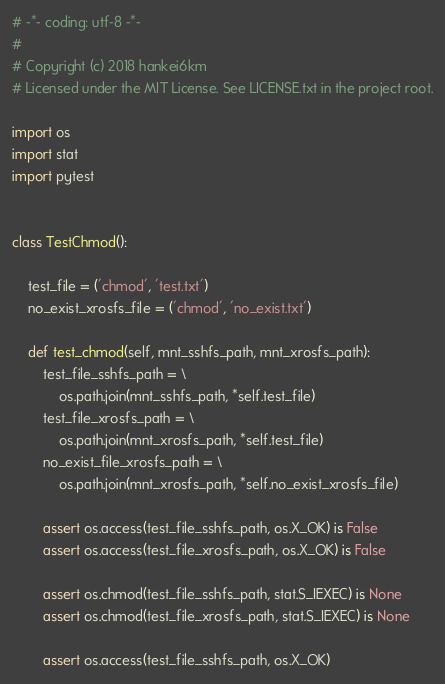Convert code to text. <code><loc_0><loc_0><loc_500><loc_500><_Python_># -*- coding: utf-8 -*-
#
# Copyright (c) 2018 hankei6km
# Licensed under the MIT License. See LICENSE.txt in the project root.

import os
import stat
import pytest


class TestChmod():

    test_file = ('chmod', 'test.txt')
    no_exist_xrosfs_file = ('chmod', 'no_exist.txt')

    def test_chmod(self, mnt_sshfs_path, mnt_xrosfs_path):
        test_file_sshfs_path = \
            os.path.join(mnt_sshfs_path, *self.test_file)
        test_file_xrosfs_path = \
            os.path.join(mnt_xrosfs_path, *self.test_file)
        no_exist_file_xrosfs_path = \
            os.path.join(mnt_xrosfs_path, *self.no_exist_xrosfs_file)

        assert os.access(test_file_sshfs_path, os.X_OK) is False
        assert os.access(test_file_xrosfs_path, os.X_OK) is False

        assert os.chmod(test_file_sshfs_path, stat.S_IEXEC) is None
        assert os.chmod(test_file_xrosfs_path, stat.S_IEXEC) is None

        assert os.access(test_file_sshfs_path, os.X_OK)</code> 